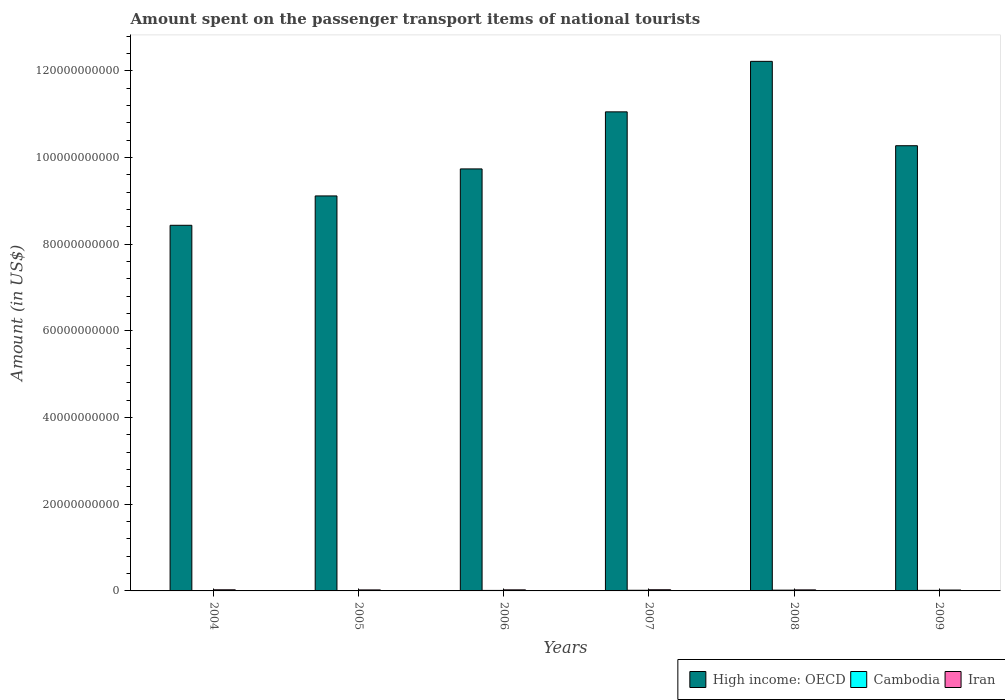How many groups of bars are there?
Ensure brevity in your answer.  6. How many bars are there on the 6th tick from the left?
Your answer should be very brief. 3. What is the amount spent on the passenger transport items of national tourists in High income: OECD in 2007?
Provide a succinct answer. 1.11e+11. Across all years, what is the maximum amount spent on the passenger transport items of national tourists in High income: OECD?
Provide a succinct answer. 1.22e+11. Across all years, what is the minimum amount spent on the passenger transport items of national tourists in Iran?
Make the answer very short. 2.04e+08. In which year was the amount spent on the passenger transport items of national tourists in Iran minimum?
Ensure brevity in your answer.  2009. What is the total amount spent on the passenger transport items of national tourists in Iran in the graph?
Your response must be concise. 1.46e+09. What is the difference between the amount spent on the passenger transport items of national tourists in Iran in 2006 and that in 2007?
Your answer should be very brief. -2.50e+07. What is the difference between the amount spent on the passenger transport items of national tourists in Cambodia in 2005 and the amount spent on the passenger transport items of national tourists in High income: OECD in 2004?
Give a very brief answer. -8.43e+1. What is the average amount spent on the passenger transport items of national tourists in Cambodia per year?
Offer a very short reply. 1.22e+08. In the year 2004, what is the difference between the amount spent on the passenger transport items of national tourists in Iran and amount spent on the passenger transport items of national tourists in High income: OECD?
Offer a very short reply. -8.41e+1. In how many years, is the amount spent on the passenger transport items of national tourists in Cambodia greater than 108000000000 US$?
Keep it short and to the point. 0. What is the ratio of the amount spent on the passenger transport items of national tourists in Cambodia in 2008 to that in 2009?
Make the answer very short. 1.41. What is the difference between the highest and the second highest amount spent on the passenger transport items of national tourists in Cambodia?
Offer a terse response. 3.00e+07. What is the difference between the highest and the lowest amount spent on the passenger transport items of national tourists in Iran?
Give a very brief answer. 6.90e+07. In how many years, is the amount spent on the passenger transport items of national tourists in Cambodia greater than the average amount spent on the passenger transport items of national tourists in Cambodia taken over all years?
Offer a terse response. 3. Is the sum of the amount spent on the passenger transport items of national tourists in Cambodia in 2004 and 2005 greater than the maximum amount spent on the passenger transport items of national tourists in High income: OECD across all years?
Offer a very short reply. No. What does the 3rd bar from the left in 2006 represents?
Provide a short and direct response. Iran. What does the 1st bar from the right in 2007 represents?
Your answer should be very brief. Iran. Is it the case that in every year, the sum of the amount spent on the passenger transport items of national tourists in Cambodia and amount spent on the passenger transport items of national tourists in Iran is greater than the amount spent on the passenger transport items of national tourists in High income: OECD?
Ensure brevity in your answer.  No. Are all the bars in the graph horizontal?
Make the answer very short. No. How many years are there in the graph?
Ensure brevity in your answer.  6. What is the difference between two consecutive major ticks on the Y-axis?
Provide a succinct answer. 2.00e+1. Are the values on the major ticks of Y-axis written in scientific E-notation?
Offer a terse response. No. What is the title of the graph?
Keep it short and to the point. Amount spent on the passenger transport items of national tourists. What is the label or title of the X-axis?
Ensure brevity in your answer.  Years. What is the label or title of the Y-axis?
Your answer should be very brief. Amount (in US$). What is the Amount (in US$) of High income: OECD in 2004?
Provide a succinct answer. 8.43e+1. What is the Amount (in US$) in Cambodia in 2004?
Your answer should be compact. 7.00e+07. What is the Amount (in US$) of Iran in 2004?
Your answer should be compact. 2.61e+08. What is the Amount (in US$) of High income: OECD in 2005?
Ensure brevity in your answer.  9.11e+1. What is the Amount (in US$) of Cambodia in 2005?
Your response must be concise. 8.90e+07. What is the Amount (in US$) in Iran in 2005?
Make the answer very short. 2.34e+08. What is the Amount (in US$) of High income: OECD in 2006?
Your answer should be very brief. 9.73e+1. What is the Amount (in US$) of Cambodia in 2006?
Offer a terse response. 1.17e+08. What is the Amount (in US$) of Iran in 2006?
Your response must be concise. 2.48e+08. What is the Amount (in US$) of High income: OECD in 2007?
Offer a terse response. 1.11e+11. What is the Amount (in US$) of Cambodia in 2007?
Provide a succinct answer. 1.49e+08. What is the Amount (in US$) in Iran in 2007?
Keep it short and to the point. 2.73e+08. What is the Amount (in US$) in High income: OECD in 2008?
Provide a succinct answer. 1.22e+11. What is the Amount (in US$) in Cambodia in 2008?
Provide a short and direct response. 1.79e+08. What is the Amount (in US$) in Iran in 2008?
Your answer should be compact. 2.41e+08. What is the Amount (in US$) in High income: OECD in 2009?
Ensure brevity in your answer.  1.03e+11. What is the Amount (in US$) of Cambodia in 2009?
Offer a terse response. 1.27e+08. What is the Amount (in US$) of Iran in 2009?
Make the answer very short. 2.04e+08. Across all years, what is the maximum Amount (in US$) of High income: OECD?
Make the answer very short. 1.22e+11. Across all years, what is the maximum Amount (in US$) in Cambodia?
Your response must be concise. 1.79e+08. Across all years, what is the maximum Amount (in US$) in Iran?
Your response must be concise. 2.73e+08. Across all years, what is the minimum Amount (in US$) of High income: OECD?
Keep it short and to the point. 8.43e+1. Across all years, what is the minimum Amount (in US$) in Cambodia?
Provide a succinct answer. 7.00e+07. Across all years, what is the minimum Amount (in US$) in Iran?
Ensure brevity in your answer.  2.04e+08. What is the total Amount (in US$) in High income: OECD in the graph?
Your response must be concise. 6.08e+11. What is the total Amount (in US$) in Cambodia in the graph?
Your response must be concise. 7.31e+08. What is the total Amount (in US$) in Iran in the graph?
Provide a short and direct response. 1.46e+09. What is the difference between the Amount (in US$) of High income: OECD in 2004 and that in 2005?
Make the answer very short. -6.77e+09. What is the difference between the Amount (in US$) in Cambodia in 2004 and that in 2005?
Your answer should be compact. -1.90e+07. What is the difference between the Amount (in US$) of Iran in 2004 and that in 2005?
Offer a very short reply. 2.70e+07. What is the difference between the Amount (in US$) in High income: OECD in 2004 and that in 2006?
Your answer should be compact. -1.30e+1. What is the difference between the Amount (in US$) in Cambodia in 2004 and that in 2006?
Make the answer very short. -4.70e+07. What is the difference between the Amount (in US$) of Iran in 2004 and that in 2006?
Provide a short and direct response. 1.30e+07. What is the difference between the Amount (in US$) in High income: OECD in 2004 and that in 2007?
Keep it short and to the point. -2.62e+1. What is the difference between the Amount (in US$) of Cambodia in 2004 and that in 2007?
Give a very brief answer. -7.90e+07. What is the difference between the Amount (in US$) in Iran in 2004 and that in 2007?
Ensure brevity in your answer.  -1.20e+07. What is the difference between the Amount (in US$) in High income: OECD in 2004 and that in 2008?
Make the answer very short. -3.78e+1. What is the difference between the Amount (in US$) of Cambodia in 2004 and that in 2008?
Ensure brevity in your answer.  -1.09e+08. What is the difference between the Amount (in US$) in High income: OECD in 2004 and that in 2009?
Your response must be concise. -1.84e+1. What is the difference between the Amount (in US$) in Cambodia in 2004 and that in 2009?
Give a very brief answer. -5.70e+07. What is the difference between the Amount (in US$) of Iran in 2004 and that in 2009?
Ensure brevity in your answer.  5.70e+07. What is the difference between the Amount (in US$) of High income: OECD in 2005 and that in 2006?
Your answer should be compact. -6.23e+09. What is the difference between the Amount (in US$) in Cambodia in 2005 and that in 2006?
Your answer should be very brief. -2.80e+07. What is the difference between the Amount (in US$) of Iran in 2005 and that in 2006?
Ensure brevity in your answer.  -1.40e+07. What is the difference between the Amount (in US$) in High income: OECD in 2005 and that in 2007?
Provide a short and direct response. -1.94e+1. What is the difference between the Amount (in US$) of Cambodia in 2005 and that in 2007?
Your response must be concise. -6.00e+07. What is the difference between the Amount (in US$) of Iran in 2005 and that in 2007?
Provide a succinct answer. -3.90e+07. What is the difference between the Amount (in US$) in High income: OECD in 2005 and that in 2008?
Your answer should be very brief. -3.10e+1. What is the difference between the Amount (in US$) of Cambodia in 2005 and that in 2008?
Your answer should be compact. -9.00e+07. What is the difference between the Amount (in US$) of Iran in 2005 and that in 2008?
Offer a terse response. -7.00e+06. What is the difference between the Amount (in US$) in High income: OECD in 2005 and that in 2009?
Give a very brief answer. -1.16e+1. What is the difference between the Amount (in US$) of Cambodia in 2005 and that in 2009?
Make the answer very short. -3.80e+07. What is the difference between the Amount (in US$) in Iran in 2005 and that in 2009?
Keep it short and to the point. 3.00e+07. What is the difference between the Amount (in US$) of High income: OECD in 2006 and that in 2007?
Ensure brevity in your answer.  -1.32e+1. What is the difference between the Amount (in US$) of Cambodia in 2006 and that in 2007?
Offer a very short reply. -3.20e+07. What is the difference between the Amount (in US$) of Iran in 2006 and that in 2007?
Your response must be concise. -2.50e+07. What is the difference between the Amount (in US$) in High income: OECD in 2006 and that in 2008?
Provide a short and direct response. -2.48e+1. What is the difference between the Amount (in US$) of Cambodia in 2006 and that in 2008?
Make the answer very short. -6.20e+07. What is the difference between the Amount (in US$) in High income: OECD in 2006 and that in 2009?
Provide a short and direct response. -5.35e+09. What is the difference between the Amount (in US$) in Cambodia in 2006 and that in 2009?
Give a very brief answer. -1.00e+07. What is the difference between the Amount (in US$) of Iran in 2006 and that in 2009?
Your answer should be very brief. 4.40e+07. What is the difference between the Amount (in US$) of High income: OECD in 2007 and that in 2008?
Give a very brief answer. -1.16e+1. What is the difference between the Amount (in US$) in Cambodia in 2007 and that in 2008?
Make the answer very short. -3.00e+07. What is the difference between the Amount (in US$) in Iran in 2007 and that in 2008?
Provide a short and direct response. 3.20e+07. What is the difference between the Amount (in US$) of High income: OECD in 2007 and that in 2009?
Make the answer very short. 7.81e+09. What is the difference between the Amount (in US$) of Cambodia in 2007 and that in 2009?
Ensure brevity in your answer.  2.20e+07. What is the difference between the Amount (in US$) in Iran in 2007 and that in 2009?
Your answer should be compact. 6.90e+07. What is the difference between the Amount (in US$) of High income: OECD in 2008 and that in 2009?
Provide a short and direct response. 1.95e+1. What is the difference between the Amount (in US$) of Cambodia in 2008 and that in 2009?
Provide a succinct answer. 5.20e+07. What is the difference between the Amount (in US$) of Iran in 2008 and that in 2009?
Your answer should be compact. 3.70e+07. What is the difference between the Amount (in US$) in High income: OECD in 2004 and the Amount (in US$) in Cambodia in 2005?
Your response must be concise. 8.43e+1. What is the difference between the Amount (in US$) of High income: OECD in 2004 and the Amount (in US$) of Iran in 2005?
Offer a very short reply. 8.41e+1. What is the difference between the Amount (in US$) of Cambodia in 2004 and the Amount (in US$) of Iran in 2005?
Offer a terse response. -1.64e+08. What is the difference between the Amount (in US$) in High income: OECD in 2004 and the Amount (in US$) in Cambodia in 2006?
Your answer should be very brief. 8.42e+1. What is the difference between the Amount (in US$) of High income: OECD in 2004 and the Amount (in US$) of Iran in 2006?
Keep it short and to the point. 8.41e+1. What is the difference between the Amount (in US$) of Cambodia in 2004 and the Amount (in US$) of Iran in 2006?
Your answer should be very brief. -1.78e+08. What is the difference between the Amount (in US$) of High income: OECD in 2004 and the Amount (in US$) of Cambodia in 2007?
Your answer should be compact. 8.42e+1. What is the difference between the Amount (in US$) in High income: OECD in 2004 and the Amount (in US$) in Iran in 2007?
Your answer should be very brief. 8.41e+1. What is the difference between the Amount (in US$) of Cambodia in 2004 and the Amount (in US$) of Iran in 2007?
Give a very brief answer. -2.03e+08. What is the difference between the Amount (in US$) in High income: OECD in 2004 and the Amount (in US$) in Cambodia in 2008?
Offer a very short reply. 8.42e+1. What is the difference between the Amount (in US$) of High income: OECD in 2004 and the Amount (in US$) of Iran in 2008?
Provide a short and direct response. 8.41e+1. What is the difference between the Amount (in US$) of Cambodia in 2004 and the Amount (in US$) of Iran in 2008?
Your response must be concise. -1.71e+08. What is the difference between the Amount (in US$) in High income: OECD in 2004 and the Amount (in US$) in Cambodia in 2009?
Offer a very short reply. 8.42e+1. What is the difference between the Amount (in US$) in High income: OECD in 2004 and the Amount (in US$) in Iran in 2009?
Give a very brief answer. 8.41e+1. What is the difference between the Amount (in US$) of Cambodia in 2004 and the Amount (in US$) of Iran in 2009?
Offer a very short reply. -1.34e+08. What is the difference between the Amount (in US$) in High income: OECD in 2005 and the Amount (in US$) in Cambodia in 2006?
Offer a very short reply. 9.10e+1. What is the difference between the Amount (in US$) in High income: OECD in 2005 and the Amount (in US$) in Iran in 2006?
Ensure brevity in your answer.  9.09e+1. What is the difference between the Amount (in US$) in Cambodia in 2005 and the Amount (in US$) in Iran in 2006?
Your answer should be very brief. -1.59e+08. What is the difference between the Amount (in US$) in High income: OECD in 2005 and the Amount (in US$) in Cambodia in 2007?
Your answer should be very brief. 9.10e+1. What is the difference between the Amount (in US$) of High income: OECD in 2005 and the Amount (in US$) of Iran in 2007?
Ensure brevity in your answer.  9.08e+1. What is the difference between the Amount (in US$) in Cambodia in 2005 and the Amount (in US$) in Iran in 2007?
Your answer should be compact. -1.84e+08. What is the difference between the Amount (in US$) in High income: OECD in 2005 and the Amount (in US$) in Cambodia in 2008?
Give a very brief answer. 9.09e+1. What is the difference between the Amount (in US$) of High income: OECD in 2005 and the Amount (in US$) of Iran in 2008?
Your answer should be very brief. 9.09e+1. What is the difference between the Amount (in US$) of Cambodia in 2005 and the Amount (in US$) of Iran in 2008?
Offer a terse response. -1.52e+08. What is the difference between the Amount (in US$) in High income: OECD in 2005 and the Amount (in US$) in Cambodia in 2009?
Provide a succinct answer. 9.10e+1. What is the difference between the Amount (in US$) of High income: OECD in 2005 and the Amount (in US$) of Iran in 2009?
Your answer should be compact. 9.09e+1. What is the difference between the Amount (in US$) of Cambodia in 2005 and the Amount (in US$) of Iran in 2009?
Offer a terse response. -1.15e+08. What is the difference between the Amount (in US$) in High income: OECD in 2006 and the Amount (in US$) in Cambodia in 2007?
Offer a terse response. 9.72e+1. What is the difference between the Amount (in US$) of High income: OECD in 2006 and the Amount (in US$) of Iran in 2007?
Provide a short and direct response. 9.71e+1. What is the difference between the Amount (in US$) of Cambodia in 2006 and the Amount (in US$) of Iran in 2007?
Offer a terse response. -1.56e+08. What is the difference between the Amount (in US$) in High income: OECD in 2006 and the Amount (in US$) in Cambodia in 2008?
Offer a terse response. 9.72e+1. What is the difference between the Amount (in US$) in High income: OECD in 2006 and the Amount (in US$) in Iran in 2008?
Offer a very short reply. 9.71e+1. What is the difference between the Amount (in US$) of Cambodia in 2006 and the Amount (in US$) of Iran in 2008?
Offer a terse response. -1.24e+08. What is the difference between the Amount (in US$) in High income: OECD in 2006 and the Amount (in US$) in Cambodia in 2009?
Give a very brief answer. 9.72e+1. What is the difference between the Amount (in US$) of High income: OECD in 2006 and the Amount (in US$) of Iran in 2009?
Provide a short and direct response. 9.71e+1. What is the difference between the Amount (in US$) of Cambodia in 2006 and the Amount (in US$) of Iran in 2009?
Offer a very short reply. -8.70e+07. What is the difference between the Amount (in US$) of High income: OECD in 2007 and the Amount (in US$) of Cambodia in 2008?
Provide a succinct answer. 1.10e+11. What is the difference between the Amount (in US$) in High income: OECD in 2007 and the Amount (in US$) in Iran in 2008?
Your answer should be compact. 1.10e+11. What is the difference between the Amount (in US$) of Cambodia in 2007 and the Amount (in US$) of Iran in 2008?
Offer a terse response. -9.20e+07. What is the difference between the Amount (in US$) in High income: OECD in 2007 and the Amount (in US$) in Cambodia in 2009?
Give a very brief answer. 1.10e+11. What is the difference between the Amount (in US$) of High income: OECD in 2007 and the Amount (in US$) of Iran in 2009?
Provide a succinct answer. 1.10e+11. What is the difference between the Amount (in US$) of Cambodia in 2007 and the Amount (in US$) of Iran in 2009?
Give a very brief answer. -5.50e+07. What is the difference between the Amount (in US$) of High income: OECD in 2008 and the Amount (in US$) of Cambodia in 2009?
Your answer should be compact. 1.22e+11. What is the difference between the Amount (in US$) of High income: OECD in 2008 and the Amount (in US$) of Iran in 2009?
Offer a terse response. 1.22e+11. What is the difference between the Amount (in US$) in Cambodia in 2008 and the Amount (in US$) in Iran in 2009?
Make the answer very short. -2.50e+07. What is the average Amount (in US$) of High income: OECD per year?
Your response must be concise. 1.01e+11. What is the average Amount (in US$) in Cambodia per year?
Give a very brief answer. 1.22e+08. What is the average Amount (in US$) in Iran per year?
Your answer should be very brief. 2.44e+08. In the year 2004, what is the difference between the Amount (in US$) of High income: OECD and Amount (in US$) of Cambodia?
Your response must be concise. 8.43e+1. In the year 2004, what is the difference between the Amount (in US$) in High income: OECD and Amount (in US$) in Iran?
Offer a terse response. 8.41e+1. In the year 2004, what is the difference between the Amount (in US$) of Cambodia and Amount (in US$) of Iran?
Your response must be concise. -1.91e+08. In the year 2005, what is the difference between the Amount (in US$) in High income: OECD and Amount (in US$) in Cambodia?
Provide a succinct answer. 9.10e+1. In the year 2005, what is the difference between the Amount (in US$) of High income: OECD and Amount (in US$) of Iran?
Make the answer very short. 9.09e+1. In the year 2005, what is the difference between the Amount (in US$) in Cambodia and Amount (in US$) in Iran?
Keep it short and to the point. -1.45e+08. In the year 2006, what is the difference between the Amount (in US$) of High income: OECD and Amount (in US$) of Cambodia?
Offer a terse response. 9.72e+1. In the year 2006, what is the difference between the Amount (in US$) of High income: OECD and Amount (in US$) of Iran?
Offer a very short reply. 9.71e+1. In the year 2006, what is the difference between the Amount (in US$) in Cambodia and Amount (in US$) in Iran?
Your response must be concise. -1.31e+08. In the year 2007, what is the difference between the Amount (in US$) in High income: OECD and Amount (in US$) in Cambodia?
Ensure brevity in your answer.  1.10e+11. In the year 2007, what is the difference between the Amount (in US$) of High income: OECD and Amount (in US$) of Iran?
Your answer should be very brief. 1.10e+11. In the year 2007, what is the difference between the Amount (in US$) of Cambodia and Amount (in US$) of Iran?
Your answer should be very brief. -1.24e+08. In the year 2008, what is the difference between the Amount (in US$) in High income: OECD and Amount (in US$) in Cambodia?
Offer a very short reply. 1.22e+11. In the year 2008, what is the difference between the Amount (in US$) of High income: OECD and Amount (in US$) of Iran?
Give a very brief answer. 1.22e+11. In the year 2008, what is the difference between the Amount (in US$) in Cambodia and Amount (in US$) in Iran?
Give a very brief answer. -6.20e+07. In the year 2009, what is the difference between the Amount (in US$) of High income: OECD and Amount (in US$) of Cambodia?
Your answer should be very brief. 1.03e+11. In the year 2009, what is the difference between the Amount (in US$) in High income: OECD and Amount (in US$) in Iran?
Provide a short and direct response. 1.02e+11. In the year 2009, what is the difference between the Amount (in US$) in Cambodia and Amount (in US$) in Iran?
Provide a short and direct response. -7.70e+07. What is the ratio of the Amount (in US$) in High income: OECD in 2004 to that in 2005?
Keep it short and to the point. 0.93. What is the ratio of the Amount (in US$) in Cambodia in 2004 to that in 2005?
Offer a very short reply. 0.79. What is the ratio of the Amount (in US$) of Iran in 2004 to that in 2005?
Make the answer very short. 1.12. What is the ratio of the Amount (in US$) of High income: OECD in 2004 to that in 2006?
Provide a short and direct response. 0.87. What is the ratio of the Amount (in US$) of Cambodia in 2004 to that in 2006?
Give a very brief answer. 0.6. What is the ratio of the Amount (in US$) of Iran in 2004 to that in 2006?
Provide a succinct answer. 1.05. What is the ratio of the Amount (in US$) in High income: OECD in 2004 to that in 2007?
Offer a very short reply. 0.76. What is the ratio of the Amount (in US$) of Cambodia in 2004 to that in 2007?
Your answer should be compact. 0.47. What is the ratio of the Amount (in US$) in Iran in 2004 to that in 2007?
Offer a very short reply. 0.96. What is the ratio of the Amount (in US$) in High income: OECD in 2004 to that in 2008?
Provide a succinct answer. 0.69. What is the ratio of the Amount (in US$) in Cambodia in 2004 to that in 2008?
Keep it short and to the point. 0.39. What is the ratio of the Amount (in US$) of Iran in 2004 to that in 2008?
Your answer should be very brief. 1.08. What is the ratio of the Amount (in US$) in High income: OECD in 2004 to that in 2009?
Your answer should be compact. 0.82. What is the ratio of the Amount (in US$) of Cambodia in 2004 to that in 2009?
Keep it short and to the point. 0.55. What is the ratio of the Amount (in US$) of Iran in 2004 to that in 2009?
Provide a succinct answer. 1.28. What is the ratio of the Amount (in US$) of High income: OECD in 2005 to that in 2006?
Provide a succinct answer. 0.94. What is the ratio of the Amount (in US$) of Cambodia in 2005 to that in 2006?
Your response must be concise. 0.76. What is the ratio of the Amount (in US$) of Iran in 2005 to that in 2006?
Offer a terse response. 0.94. What is the ratio of the Amount (in US$) of High income: OECD in 2005 to that in 2007?
Your response must be concise. 0.82. What is the ratio of the Amount (in US$) in Cambodia in 2005 to that in 2007?
Your response must be concise. 0.6. What is the ratio of the Amount (in US$) in High income: OECD in 2005 to that in 2008?
Keep it short and to the point. 0.75. What is the ratio of the Amount (in US$) of Cambodia in 2005 to that in 2008?
Make the answer very short. 0.5. What is the ratio of the Amount (in US$) in High income: OECD in 2005 to that in 2009?
Ensure brevity in your answer.  0.89. What is the ratio of the Amount (in US$) of Cambodia in 2005 to that in 2009?
Ensure brevity in your answer.  0.7. What is the ratio of the Amount (in US$) of Iran in 2005 to that in 2009?
Your response must be concise. 1.15. What is the ratio of the Amount (in US$) in High income: OECD in 2006 to that in 2007?
Make the answer very short. 0.88. What is the ratio of the Amount (in US$) in Cambodia in 2006 to that in 2007?
Give a very brief answer. 0.79. What is the ratio of the Amount (in US$) of Iran in 2006 to that in 2007?
Provide a short and direct response. 0.91. What is the ratio of the Amount (in US$) of High income: OECD in 2006 to that in 2008?
Offer a very short reply. 0.8. What is the ratio of the Amount (in US$) of Cambodia in 2006 to that in 2008?
Your response must be concise. 0.65. What is the ratio of the Amount (in US$) of Iran in 2006 to that in 2008?
Make the answer very short. 1.03. What is the ratio of the Amount (in US$) of High income: OECD in 2006 to that in 2009?
Give a very brief answer. 0.95. What is the ratio of the Amount (in US$) in Cambodia in 2006 to that in 2009?
Provide a short and direct response. 0.92. What is the ratio of the Amount (in US$) of Iran in 2006 to that in 2009?
Your answer should be very brief. 1.22. What is the ratio of the Amount (in US$) of High income: OECD in 2007 to that in 2008?
Keep it short and to the point. 0.9. What is the ratio of the Amount (in US$) in Cambodia in 2007 to that in 2008?
Offer a very short reply. 0.83. What is the ratio of the Amount (in US$) in Iran in 2007 to that in 2008?
Your response must be concise. 1.13. What is the ratio of the Amount (in US$) in High income: OECD in 2007 to that in 2009?
Offer a terse response. 1.08. What is the ratio of the Amount (in US$) in Cambodia in 2007 to that in 2009?
Give a very brief answer. 1.17. What is the ratio of the Amount (in US$) of Iran in 2007 to that in 2009?
Give a very brief answer. 1.34. What is the ratio of the Amount (in US$) in High income: OECD in 2008 to that in 2009?
Offer a very short reply. 1.19. What is the ratio of the Amount (in US$) of Cambodia in 2008 to that in 2009?
Provide a succinct answer. 1.41. What is the ratio of the Amount (in US$) of Iran in 2008 to that in 2009?
Your answer should be compact. 1.18. What is the difference between the highest and the second highest Amount (in US$) of High income: OECD?
Your answer should be compact. 1.16e+1. What is the difference between the highest and the second highest Amount (in US$) of Cambodia?
Provide a short and direct response. 3.00e+07. What is the difference between the highest and the lowest Amount (in US$) in High income: OECD?
Offer a very short reply. 3.78e+1. What is the difference between the highest and the lowest Amount (in US$) of Cambodia?
Your answer should be very brief. 1.09e+08. What is the difference between the highest and the lowest Amount (in US$) of Iran?
Provide a short and direct response. 6.90e+07. 